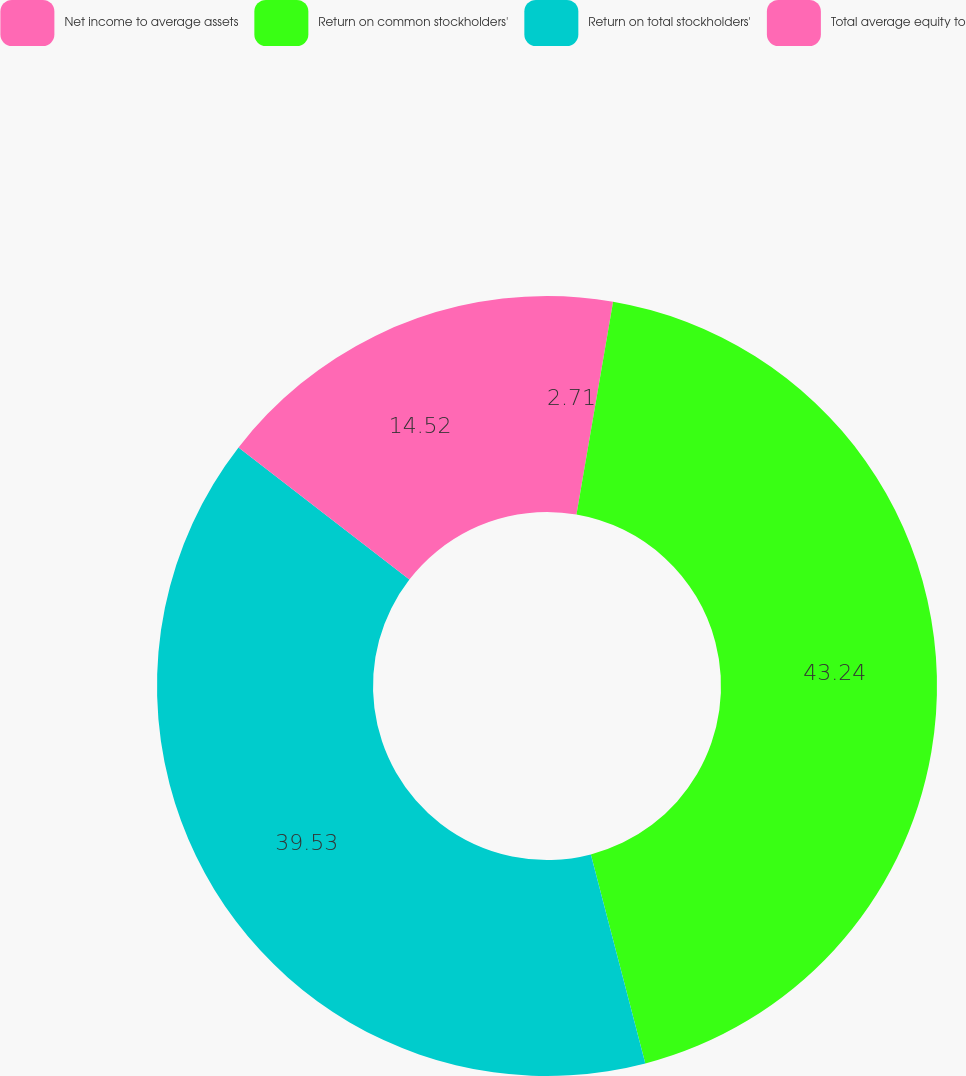Convert chart to OTSL. <chart><loc_0><loc_0><loc_500><loc_500><pie_chart><fcel>Net income to average assets<fcel>Return on common stockholders'<fcel>Return on total stockholders'<fcel>Total average equity to<nl><fcel>2.71%<fcel>43.23%<fcel>39.53%<fcel>14.52%<nl></chart> 